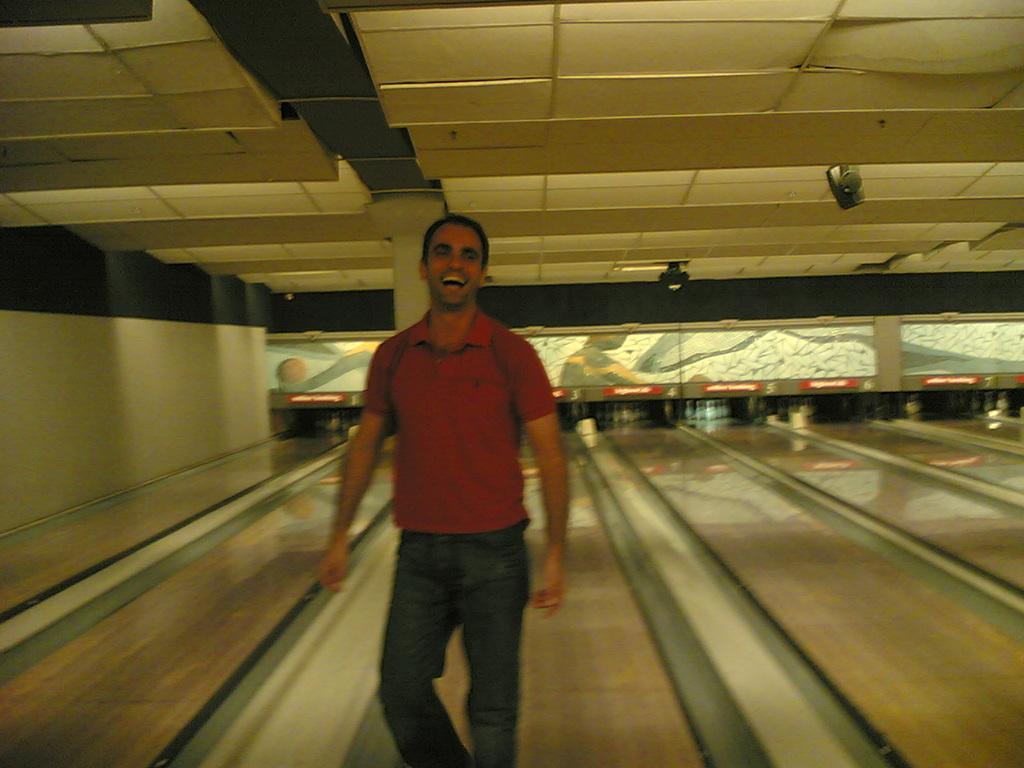How would you summarize this image in a sentence or two? In the image there is a man with red t-shirt is standing and he is smiling. Behind him there is a blowing. At the top of the image there is a roof with pillars. 